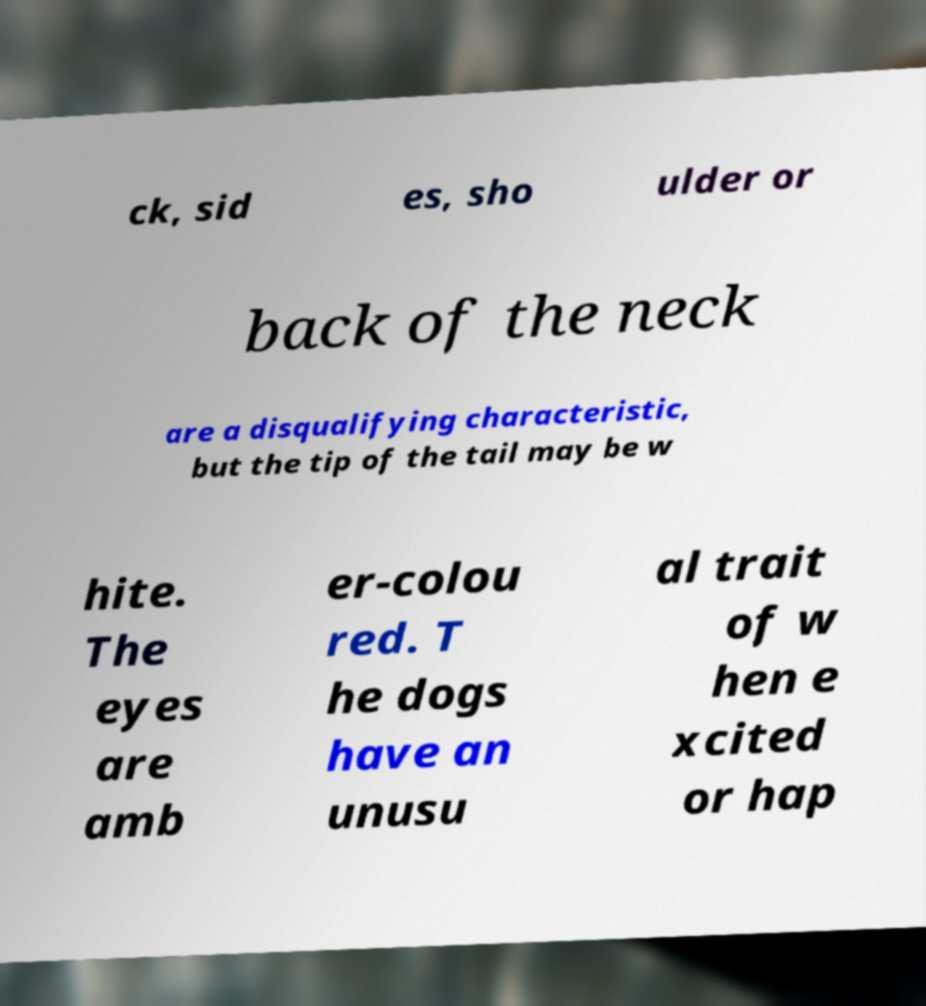Could you extract and type out the text from this image? ck, sid es, sho ulder or back of the neck are a disqualifying characteristic, but the tip of the tail may be w hite. The eyes are amb er-colou red. T he dogs have an unusu al trait of w hen e xcited or hap 